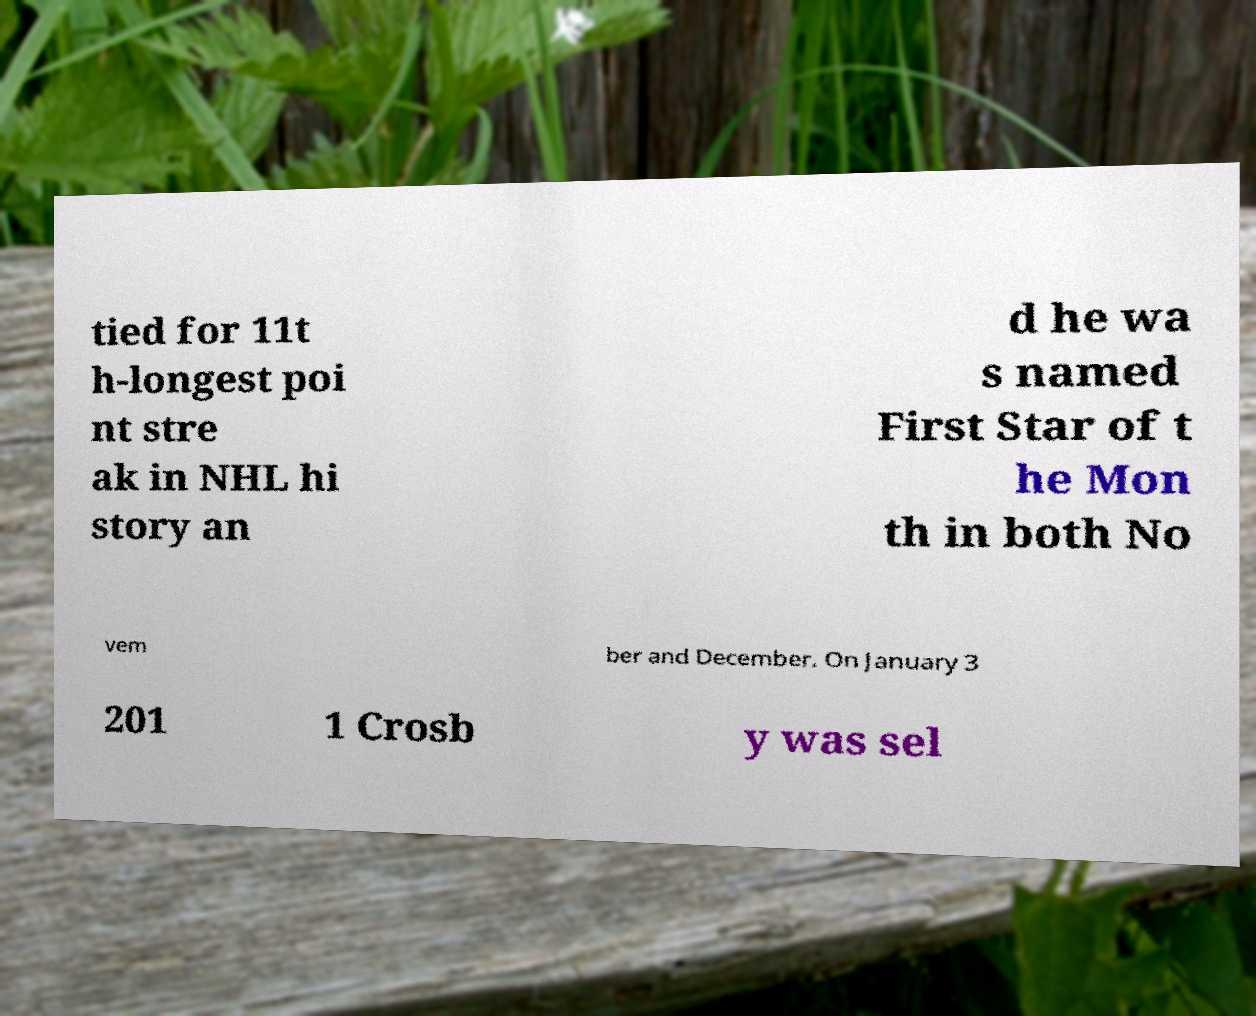Could you extract and type out the text from this image? tied for 11t h-longest poi nt stre ak in NHL hi story an d he wa s named First Star of t he Mon th in both No vem ber and December. On January 3 201 1 Crosb y was sel 